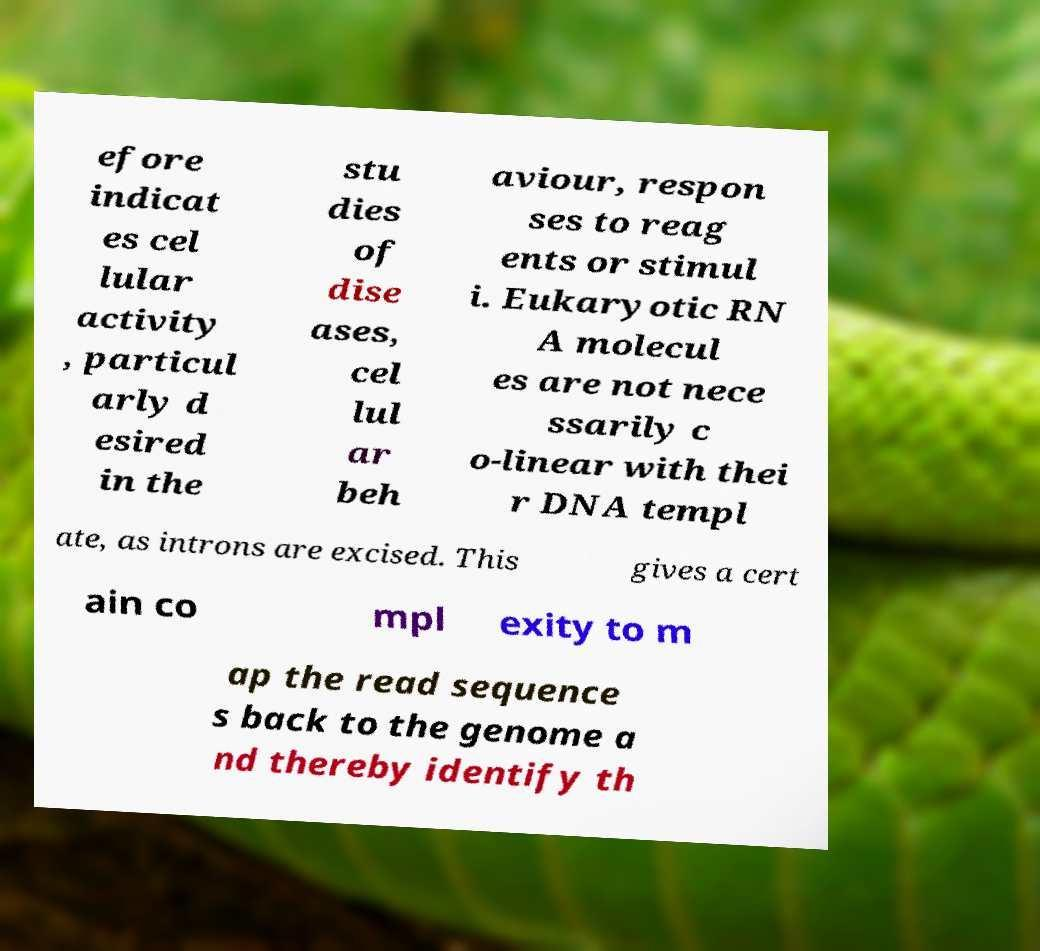Could you assist in decoding the text presented in this image and type it out clearly? efore indicat es cel lular activity , particul arly d esired in the stu dies of dise ases, cel lul ar beh aviour, respon ses to reag ents or stimul i. Eukaryotic RN A molecul es are not nece ssarily c o-linear with thei r DNA templ ate, as introns are excised. This gives a cert ain co mpl exity to m ap the read sequence s back to the genome a nd thereby identify th 